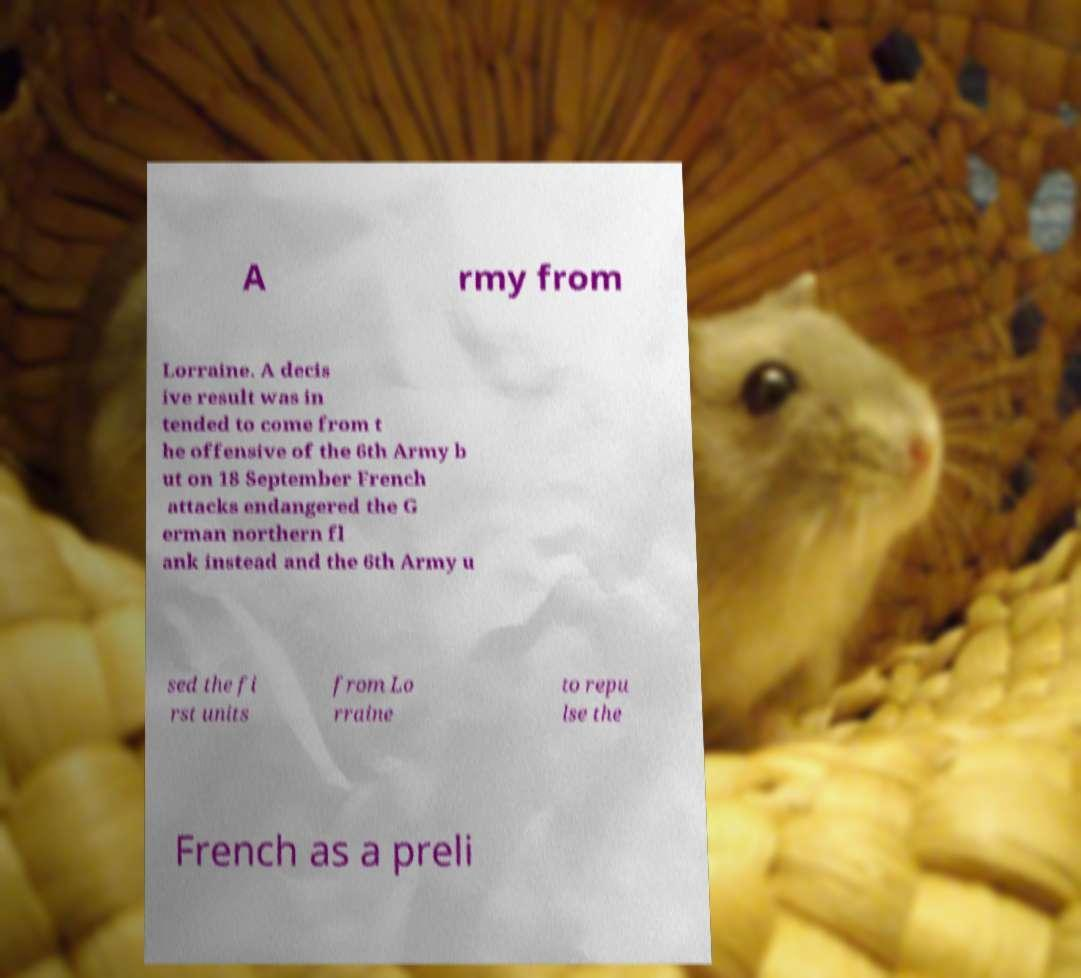Please read and relay the text visible in this image. What does it say? A rmy from Lorraine. A decis ive result was in tended to come from t he offensive of the 6th Army b ut on 18 September French attacks endangered the G erman northern fl ank instead and the 6th Army u sed the fi rst units from Lo rraine to repu lse the French as a preli 